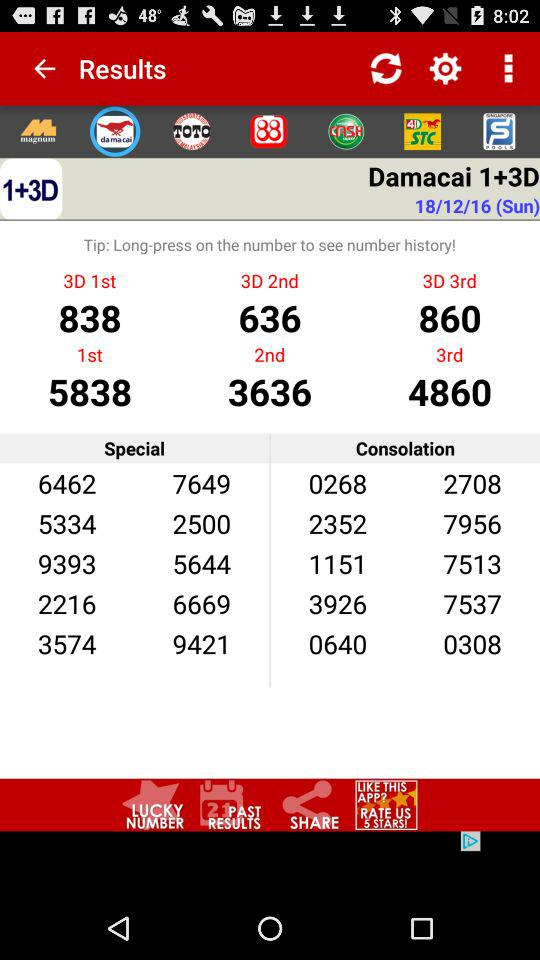What’s the number for the second prize for 3D?
When the provided information is insufficient, respond with <no answer>. <no answer> 